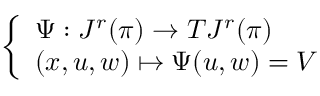Convert formula to latex. <formula><loc_0><loc_0><loc_500><loc_500>\left \{ \begin{array} { l l } { \Psi \colon J ^ { r } ( \pi ) \to T J ^ { r } ( \pi ) } \\ { ( x , u , w ) \mapsto \Psi ( u , w ) = V } \end{array}</formula> 